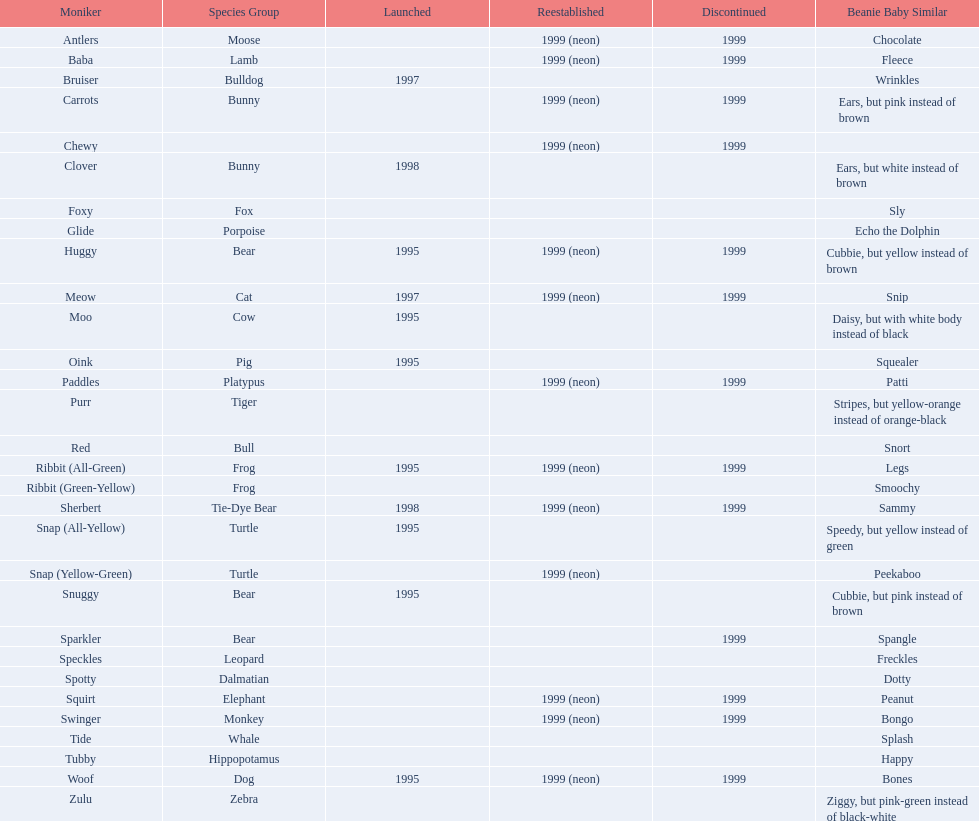What are all the pillow pals? Antlers, Baba, Bruiser, Carrots, Chewy, Clover, Foxy, Glide, Huggy, Meow, Moo, Oink, Paddles, Purr, Red, Ribbit (All-Green), Ribbit (Green-Yellow), Sherbert, Snap (All-Yellow), Snap (Yellow-Green), Snuggy, Sparkler, Speckles, Spotty, Squirt, Swinger, Tide, Tubby, Woof, Zulu. Which is the only without a listed animal type? Chewy. 